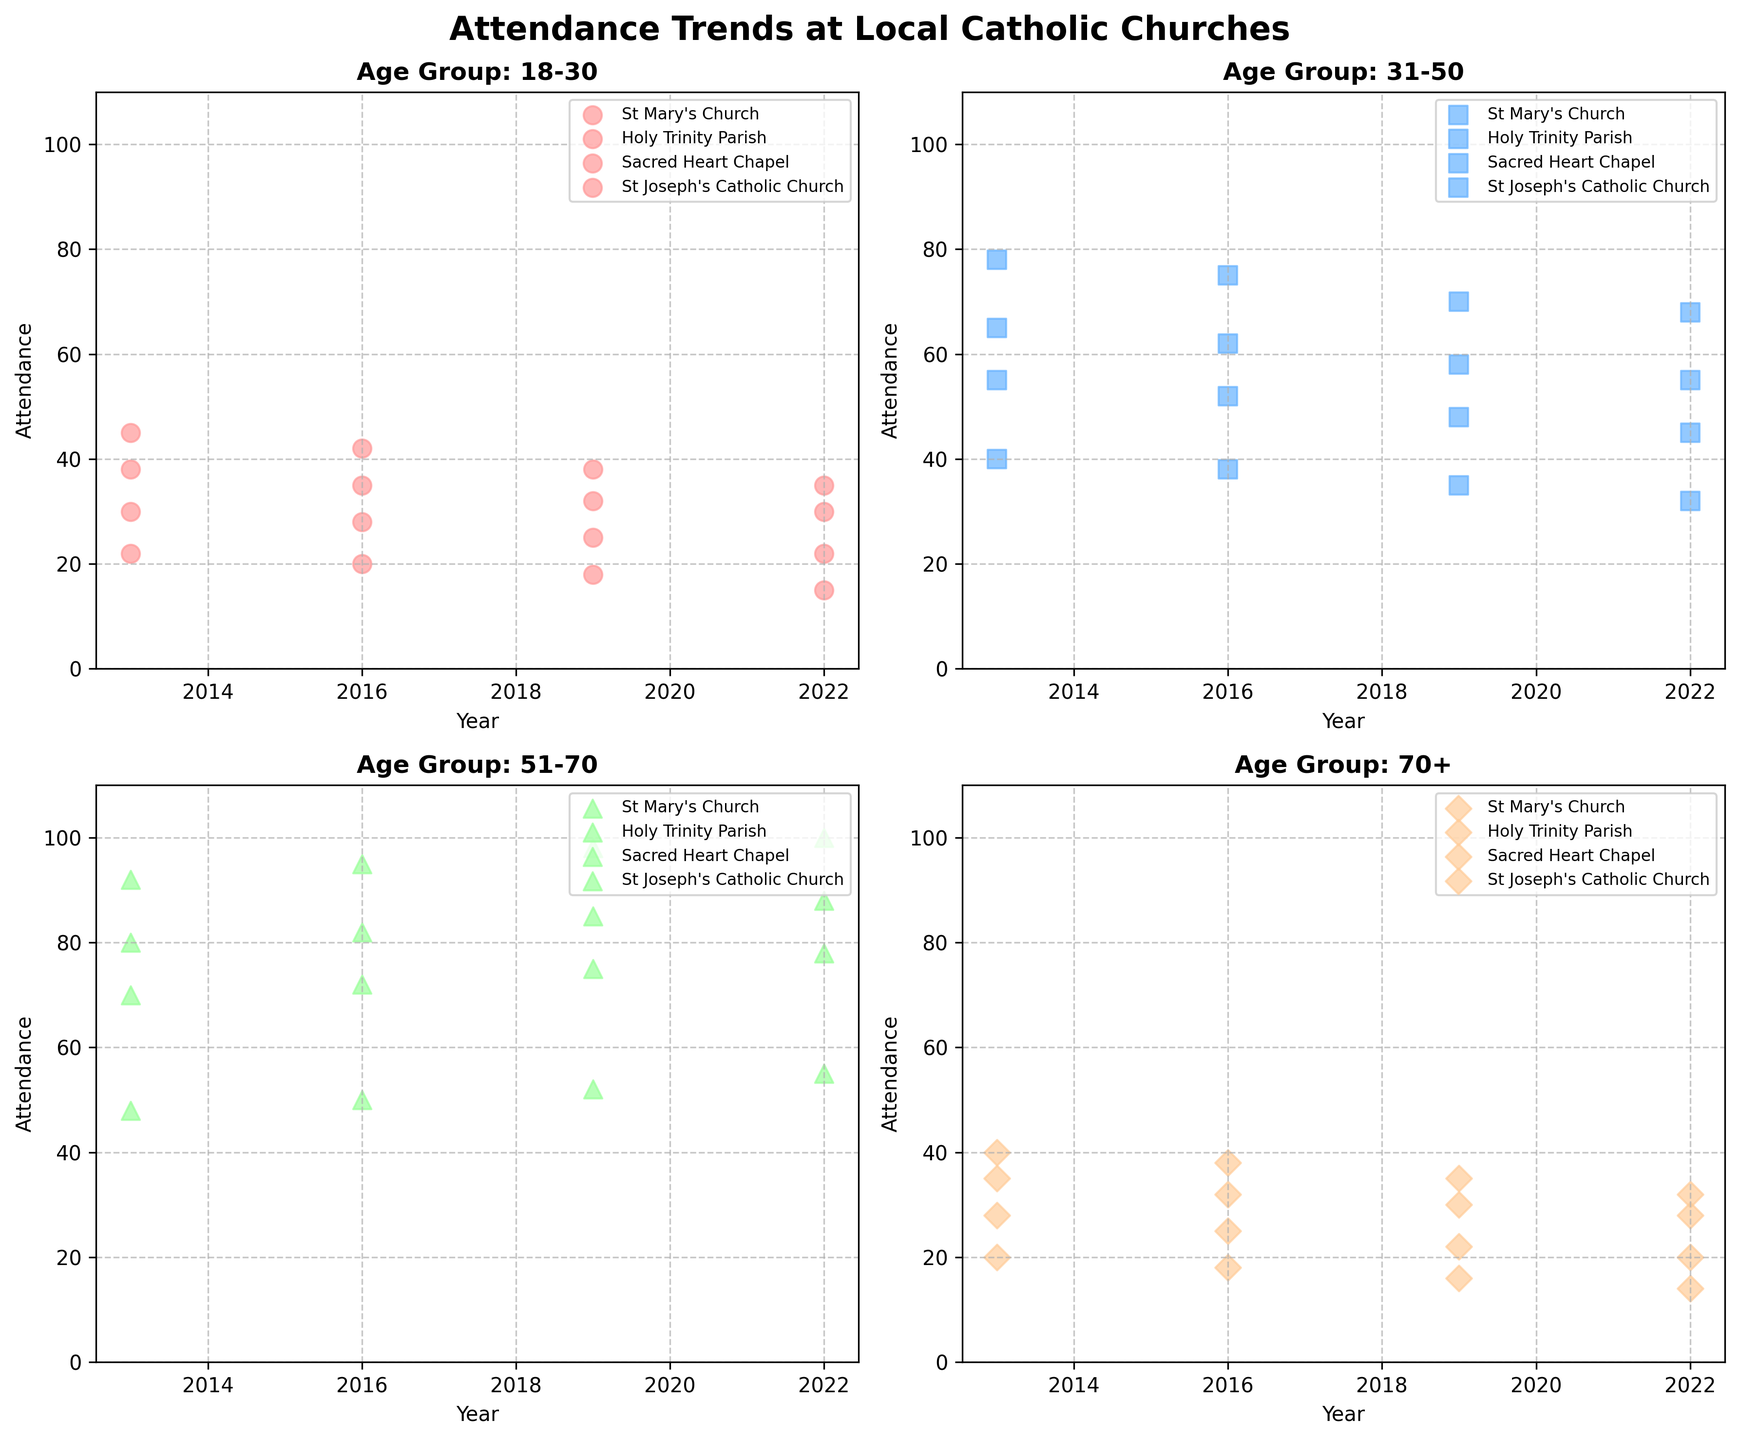Is the attendance at St. Mary's Church for the 51-70 age group increasing or decreasing over the years? Observe the attendance values for the 51-70 age group at St. Mary's Church from 2013 to 2022: 92, 95, 98, 100. These values are increasing each year.
Answer: Increasing Which church has the lowest attendance among the 18-30 age group in 2022? Compare the 2022 values for each church in the 18-30 age group: St. Mary's (35), Holy Trinity (30), Sacred Heart (15), St. Joseph's (22). Sacred Heart Chapel has the lowest value.
Answer: Sacred Heart Chapel What is the average attendance at Holy Trinity Parish for the 31-50 age group across all given years? Add the attendance values for Holy Trinity Parish in the 31-50 age group: 65 + 62 + 58 + 55, then divide by the number of years: (65 + 62 + 58 + 55)/4 = 60.
Answer: 60 Which age group at St. Joseph's Catholic Church experienced the biggest drop in attendance from 2013 to 2022? Calculate the drop in attendance for each age group from 2013 to 2022: 
- 18-30: 30 to 22 (drop of 8)
- 31-50: 55 to 45 (drop of 10)
- 51-70: 70 to 78 (increase of 8)
- 70+: 28 to 20 (drop of 8)
The 31-50 age group has the largest drop of 10.
Answer: 31-50 In 2019, which church had the highest attendance for the 51-70 age group? Compare the 2019 values for each church in the 51-70 age group: St. Mary's (98), Holy Trinity (85), Sacred Heart (52), St. Joseph's (75). St. Mary's Church has the highest value.
Answer: St. Mary's Church Across all years, which age group consistently has the highest attendance at the Sacred Heart Chapel? Compare the attendance values of each age group over all years for Sacred Heart Chapel:
- 18-30: 22, 20, 18, 15
- 31-50: 40, 38, 35, 32
- 51-70: 48, 50, 52, 55
- 70+: 20, 18, 16, 14
The 51-70 age group consistently has the highest values.
Answer: 51-70 Between 2013 and 2022, which age group at Holy Trinity Parish shows the most significant decline in attendance percentage-wise? Calculate the percentage decline for each age group from 2013 to 2022 at Holy Trinity Parish:
- 18-30: (38 - 30)/38 = 8/38 ≈ 0.21 (21%)
- 31-50: (65 - 55)/65 = 10/65 ≈ 0.15 (15%)
- 51-70: (80 - 88)/80 = -8/80 = -0.1 (increase)
- 70+: (35 - 28)/35 = 7/35 ≈ 0.2 (20%)
The 18-30 age group shows the largest percentage decline of 21%.
Answer: 18-30 